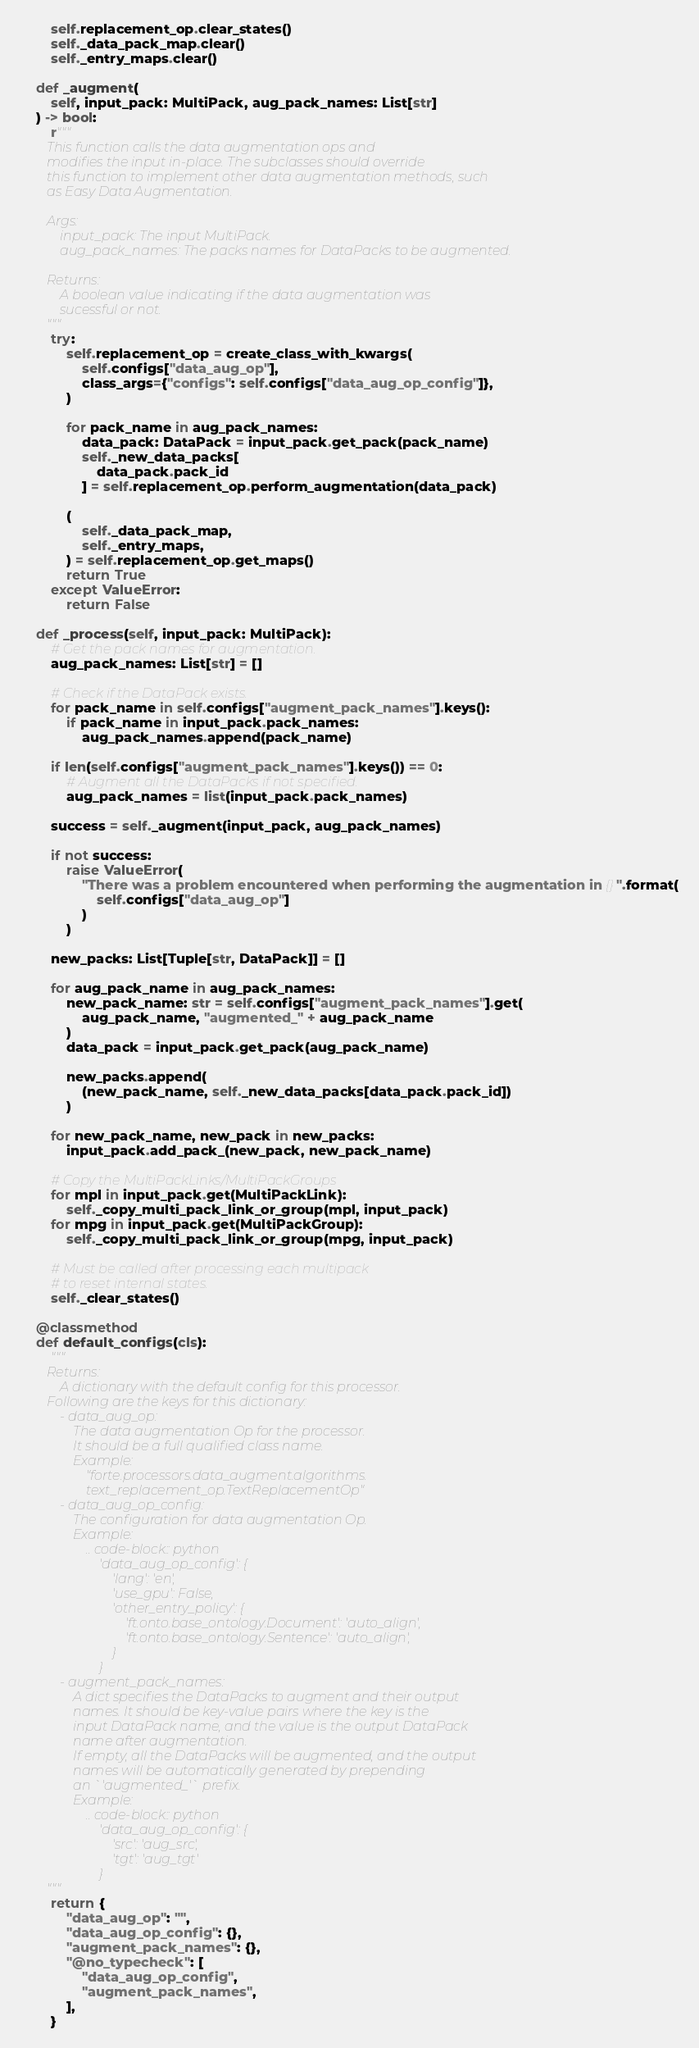<code> <loc_0><loc_0><loc_500><loc_500><_Python_>        self.replacement_op.clear_states()
        self._data_pack_map.clear()
        self._entry_maps.clear()

    def _augment(
        self, input_pack: MultiPack, aug_pack_names: List[str]
    ) -> bool:
        r"""
        This function calls the data augmentation ops and
        modifies the input in-place. The subclasses should override
        this function to implement other data augmentation methods, such
        as Easy Data Augmentation.

        Args:
            input_pack: The input MultiPack.
            aug_pack_names: The packs names for DataPacks to be augmented.

        Returns:
            A boolean value indicating if the data augmentation was
            sucessful or not.
        """
        try:
            self.replacement_op = create_class_with_kwargs(
                self.configs["data_aug_op"],
                class_args={"configs": self.configs["data_aug_op_config"]},
            )

            for pack_name in aug_pack_names:
                data_pack: DataPack = input_pack.get_pack(pack_name)
                self._new_data_packs[
                    data_pack.pack_id
                ] = self.replacement_op.perform_augmentation(data_pack)

            (
                self._data_pack_map,
                self._entry_maps,
            ) = self.replacement_op.get_maps()
            return True
        except ValueError:
            return False

    def _process(self, input_pack: MultiPack):
        # Get the pack names for augmentation.
        aug_pack_names: List[str] = []

        # Check if the DataPack exists.
        for pack_name in self.configs["augment_pack_names"].keys():
            if pack_name in input_pack.pack_names:
                aug_pack_names.append(pack_name)

        if len(self.configs["augment_pack_names"].keys()) == 0:
            # Augment all the DataPacks if not specified.
            aug_pack_names = list(input_pack.pack_names)

        success = self._augment(input_pack, aug_pack_names)

        if not success:
            raise ValueError(
                "There was a problem encountered when performing the augmentation in {}".format(
                    self.configs["data_aug_op"]
                )
            )

        new_packs: List[Tuple[str, DataPack]] = []

        for aug_pack_name in aug_pack_names:
            new_pack_name: str = self.configs["augment_pack_names"].get(
                aug_pack_name, "augmented_" + aug_pack_name
            )
            data_pack = input_pack.get_pack(aug_pack_name)

            new_packs.append(
                (new_pack_name, self._new_data_packs[data_pack.pack_id])
            )

        for new_pack_name, new_pack in new_packs:
            input_pack.add_pack_(new_pack, new_pack_name)

        # Copy the MultiPackLinks/MultiPackGroups
        for mpl in input_pack.get(MultiPackLink):
            self._copy_multi_pack_link_or_group(mpl, input_pack)
        for mpg in input_pack.get(MultiPackGroup):
            self._copy_multi_pack_link_or_group(mpg, input_pack)

        # Must be called after processing each multipack
        # to reset internal states.
        self._clear_states()

    @classmethod
    def default_configs(cls):
        """
        Returns:
            A dictionary with the default config for this processor.
        Following are the keys for this dictionary:
            - data_aug_op:
                The data augmentation Op for the processor.
                It should be a full qualified class name.
                Example:
                    "forte.processors.data_augment.algorithms.
                    text_replacement_op.TextReplacementOp"
            - data_aug_op_config:
                The configuration for data augmentation Op.
                Example:
                    .. code-block:: python
                        'data_aug_op_config': {
                            'lang': 'en',
                            'use_gpu': False,
                            'other_entry_policy': {
                                'ft.onto.base_ontology.Document': 'auto_align',
                                'ft.onto.base_ontology.Sentence': 'auto_align',
                            }
                        }
            - augment_pack_names:
                A dict specifies the DataPacks to augment and their output
                names. It should be key-value pairs where the key is the
                input DataPack name, and the value is the output DataPack
                name after augmentation.
                If empty, all the DataPacks will be augmented, and the output
                names will be automatically generated by prepending
                an `'augmented_'` prefix.
                Example:
                    .. code-block:: python
                        'data_aug_op_config': {
                            'src': 'aug_src',
                            'tgt': 'aug_tgt'
                        }
        """
        return {
            "data_aug_op": "",
            "data_aug_op_config": {},
            "augment_pack_names": {},
            "@no_typecheck": [
                "data_aug_op_config",
                "augment_pack_names",
            ],
        }
</code> 